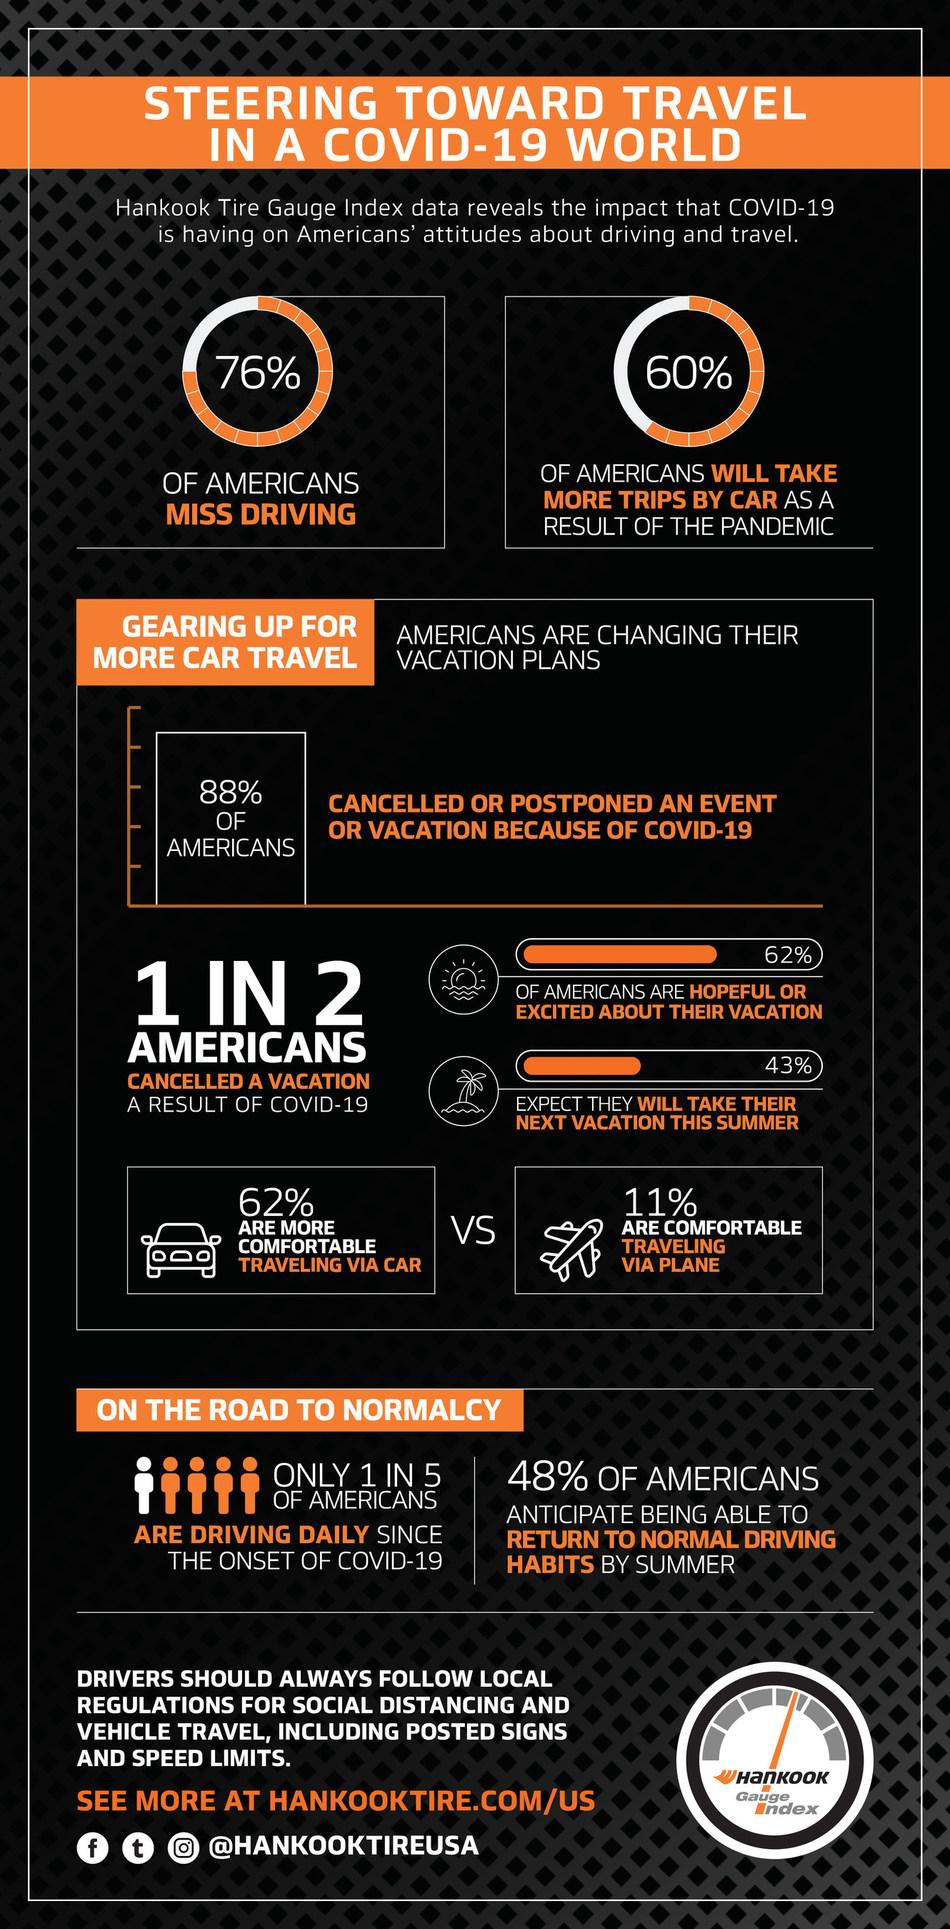Give some essential details in this illustration. According to a recent survey, 38% of Americans do not have hope for their upcoming vacation. According to the given information, approximately 38% of people are not comfortable traveling via car. According to a recent survey, a staggering 89% of people reported feeling uncomfortable or anxious while traveling via plane. According to a recent survey, 24% of Americans do not miss driving. 